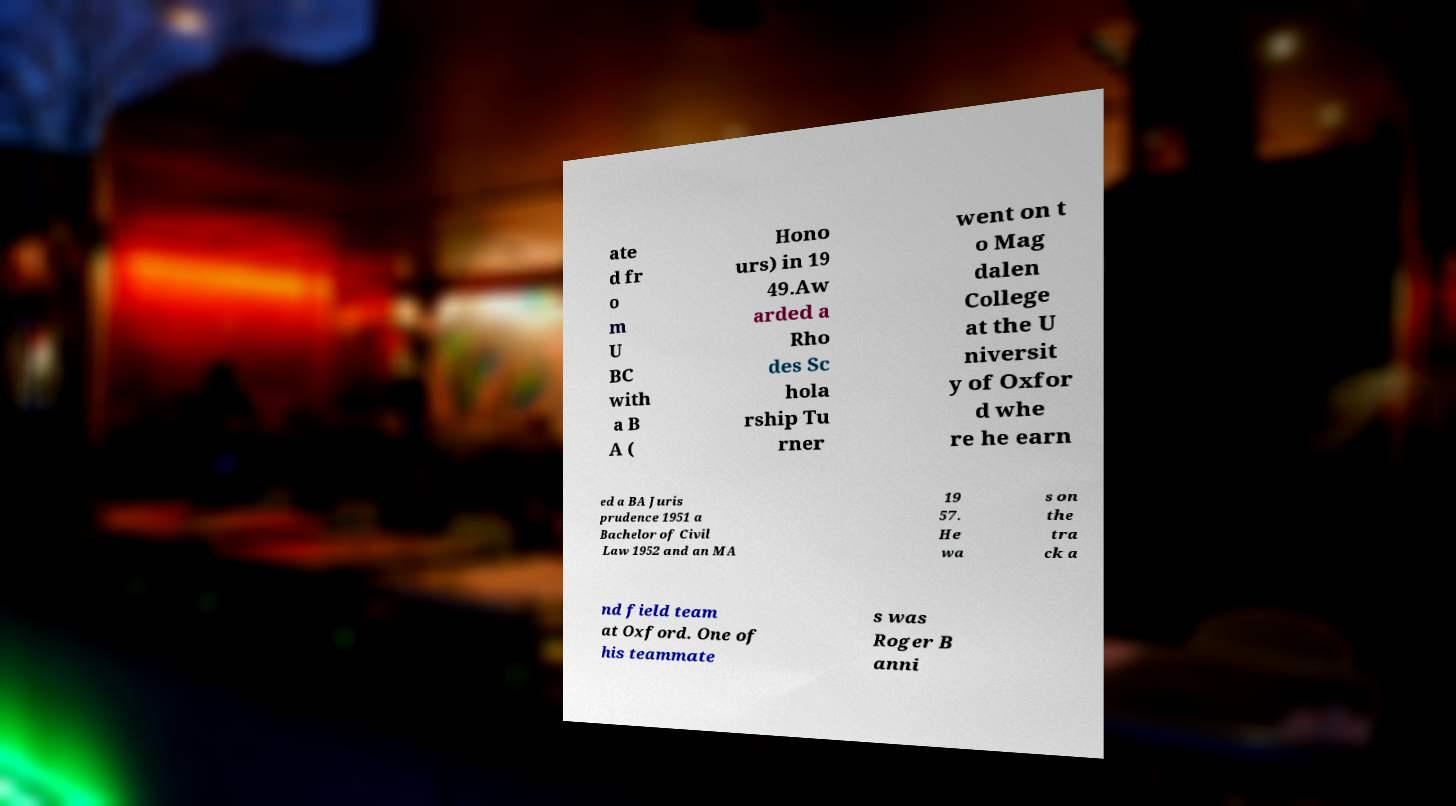For documentation purposes, I need the text within this image transcribed. Could you provide that? ate d fr o m U BC with a B A ( Hono urs) in 19 49.Aw arded a Rho des Sc hola rship Tu rner went on t o Mag dalen College at the U niversit y of Oxfor d whe re he earn ed a BA Juris prudence 1951 a Bachelor of Civil Law 1952 and an MA 19 57. He wa s on the tra ck a nd field team at Oxford. One of his teammate s was Roger B anni 